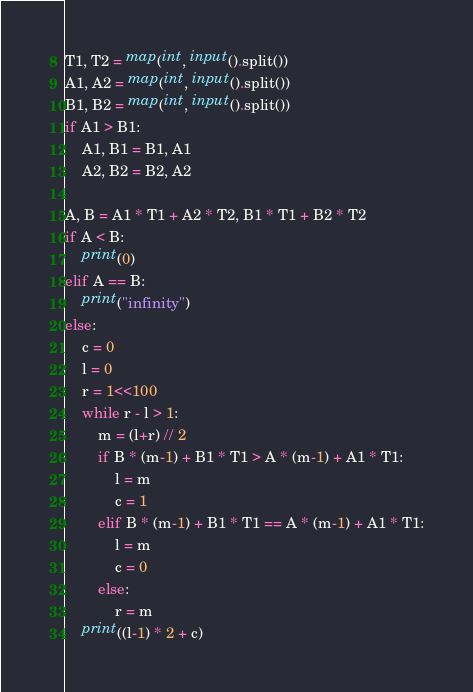<code> <loc_0><loc_0><loc_500><loc_500><_Python_>T1, T2 = map(int, input().split())
A1, A2 = map(int, input().split())
B1, B2 = map(int, input().split())
if A1 > B1:
    A1, B1 = B1, A1
    A2, B2 = B2, A2

A, B = A1 * T1 + A2 * T2, B1 * T1 + B2 * T2
if A < B:
    print(0)
elif A == B:
    print("infinity")
else:
    c = 0
    l = 0
    r = 1<<100
    while r - l > 1:
        m = (l+r) // 2
        if B * (m-1) + B1 * T1 > A * (m-1) + A1 * T1:
            l = m
            c = 1
        elif B * (m-1) + B1 * T1 == A * (m-1) + A1 * T1:
            l = m
            c = 0
        else:
            r = m
    print((l-1) * 2 + c)</code> 